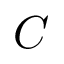Convert formula to latex. <formula><loc_0><loc_0><loc_500><loc_500>C</formula> 